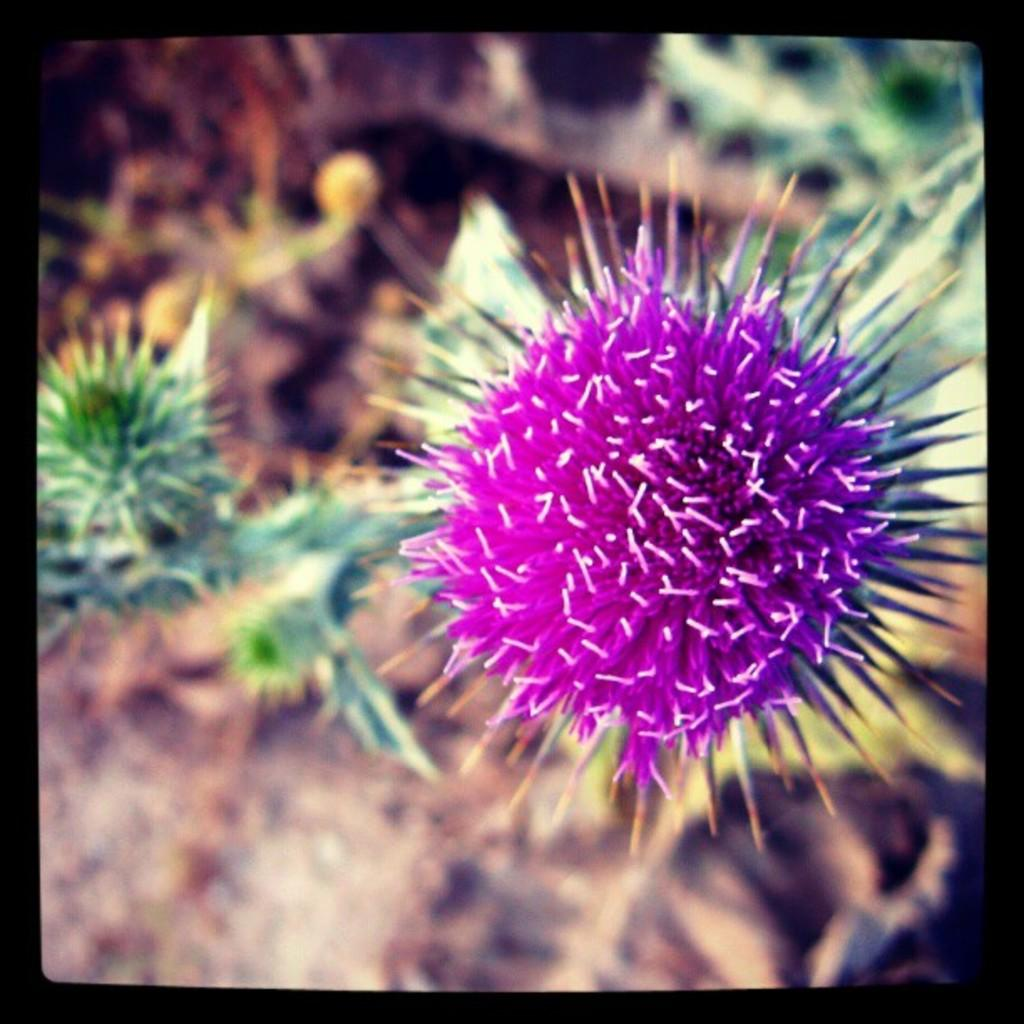What type of plant is present in the image? The image contains a flower plant. Can you describe the background of the image? The background of the image is blurred. What type of boat can be seen in the background of the image? There is no boat present in the image; the background is blurred. What type of stew is being prepared in the image? There is no stew or cooking activity present in the image; it features a flower plant. 